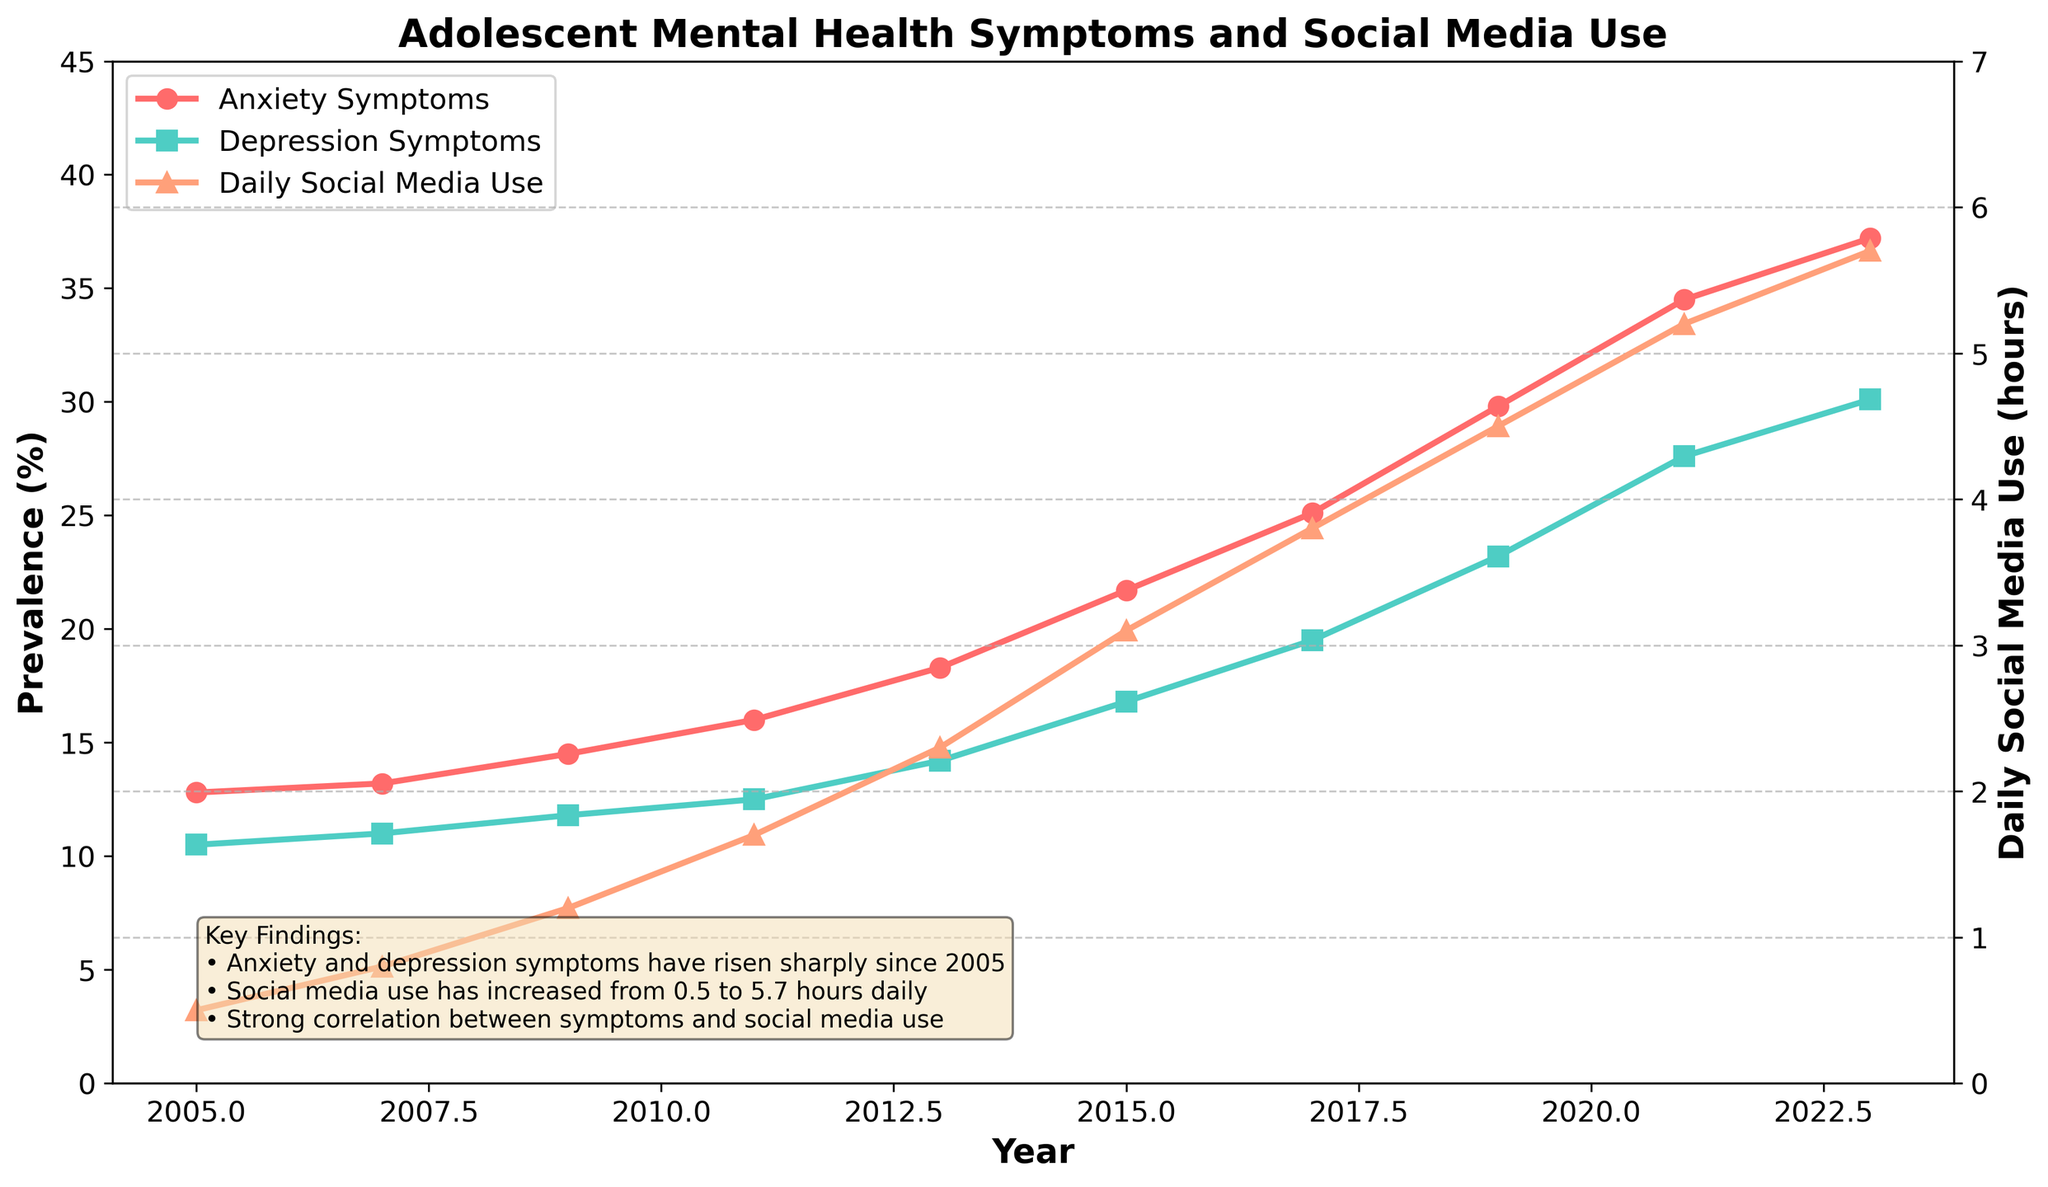What trend do you observe in anxiety symptoms from 2005 to 2023? From the figure, you can see that the percentage of anxiety symptoms in adolescents has increased from 12.8% in 2005 to 37.2% in 2023. This indicates a rising trend over the years.
Answer: Increasing How much did depression symptoms increase from 2005 to 2023? The figure shows that depression symptoms increased from 10.5% in 2005 to 30.1% in 2023. The increase can be calculated as 30.1% - 10.5% = 19.6%.
Answer: 19.6% In which year did daily social media use surpass 3 hours? By examining the trend line for daily social media use, it reaches above 3 hours sometime between 2015 (3.1 hours) and 2017 (3.8 hours).
Answer: 2015 Which year experienced the sharpest rise in anxiety symptoms? By looking at the steepness of the anxiety symptoms line, the period between 2011 and 2013 shows a significant rise from 16.0% to 18.3%, suggesting the sharpest rise.
Answer: 2011 to 2013 Compare the rate of increase in anxiety symptoms and social media use between 2005 and 2023. Which grew faster? Anxiety symptoms increased from 12.8% to 37.2% (a 24.4% rise), while social media use increased from 0.5 to 5.7 hours (a 5.2-hour rise). To compare rates, convert both to percentages relative to their starting values: Anxiety: (24.4/12.8) * 100 ≈ 190%, Social Media: (5.2/0.5) * 100 ≈ 1040%. Social media use grew faster.
Answer: Social Media Use What was the depression symptom prevalence in 2013 and how does it compare to social media use in the same year? In 2013, depression symptoms were at 14.2%, while daily social media use was at 2.3 hours. While both values are through different metrics, you can observe that the social media use increased while so did depression symptoms.
Answer: 14.2% and 2.3 hours Which variable showed the smallest increase between 2005 and 2023, anxiety symptoms, depression symptoms, or social media use? By calculating the increases: Anxiety Symptoms increased by 24.4% (37.2% - 12.8%), Depression Symptoms by 19.6% (30.1% - 10.5%), and Social Media Use by 5.2 hours (5.7 - 0.5). The smallest increment is in Social Media Use.
Answer: Social Media Use Is there a year where both the anxiety and depression symptoms show an equal increase? By observing the parallel nature of the lines, look for any equal-sized vertical jumps in both lines between consecutive years. This is not immediately observed as the increments are different across years.
Answer: No 